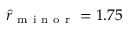Convert formula to latex. <formula><loc_0><loc_0><loc_500><loc_500>\hat { r } _ { m i n o r } = 1 . 7 5</formula> 